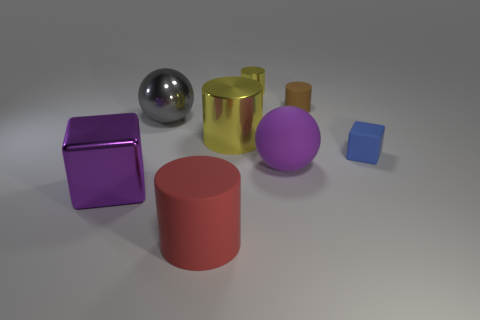Subtract all tiny yellow metal cylinders. How many cylinders are left? 3 Subtract all cubes. How many objects are left? 6 Add 1 tiny cubes. How many objects exist? 9 Add 7 large blocks. How many large blocks are left? 8 Add 1 small cubes. How many small cubes exist? 2 Subtract all purple blocks. How many blocks are left? 1 Subtract 1 purple spheres. How many objects are left? 7 Subtract 1 balls. How many balls are left? 1 Subtract all brown blocks. Subtract all red cylinders. How many blocks are left? 2 Subtract all red cubes. How many green cylinders are left? 0 